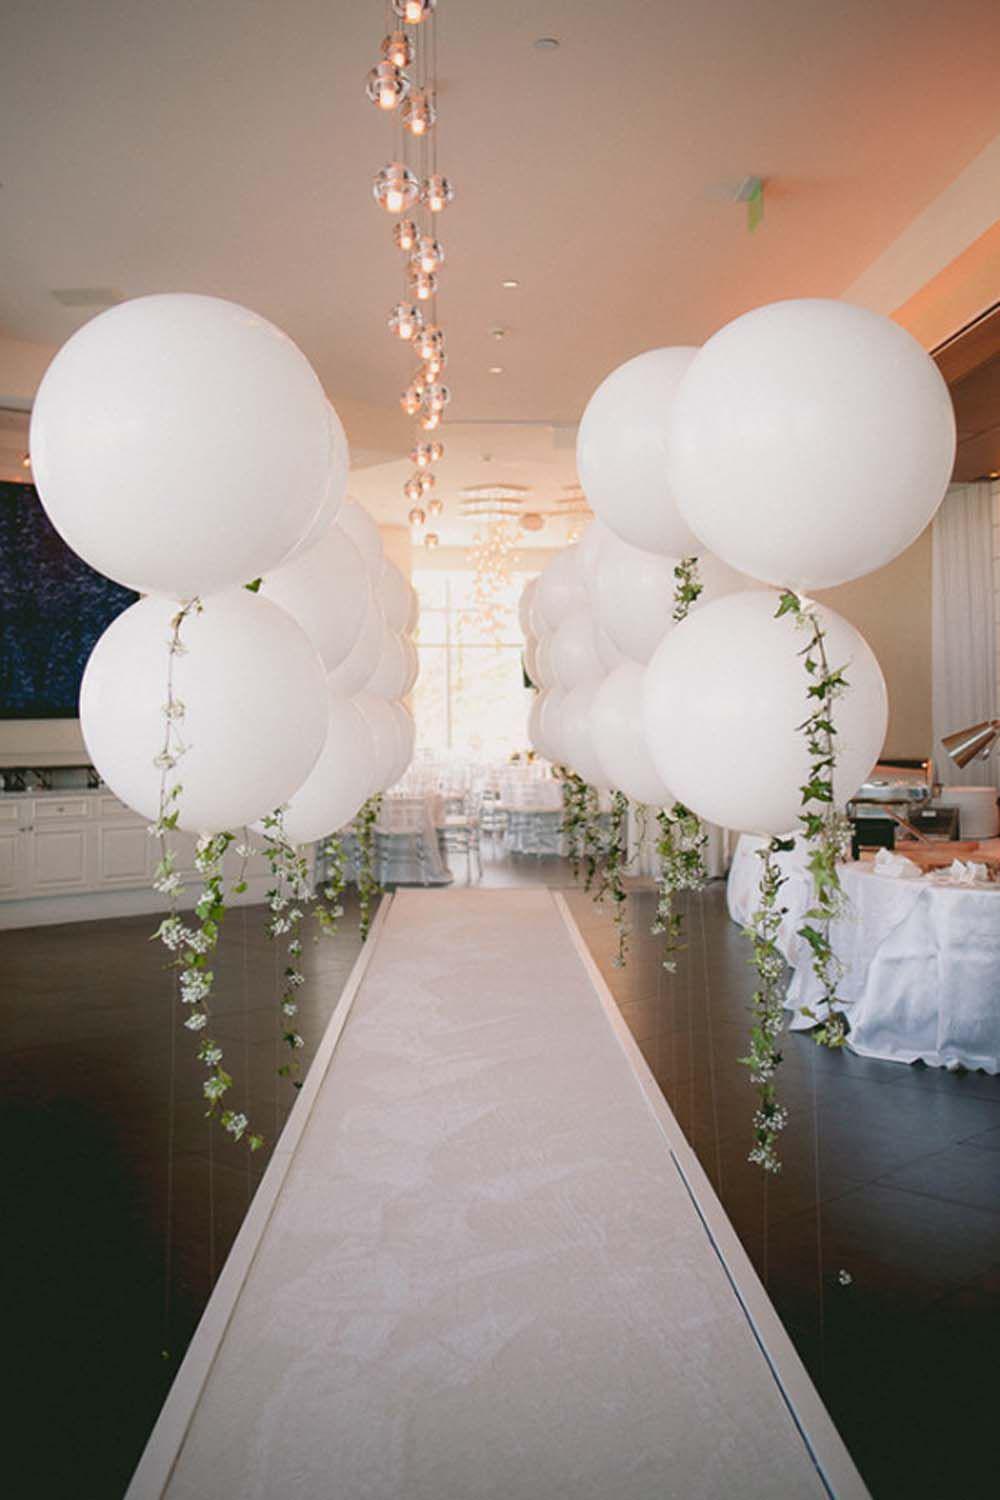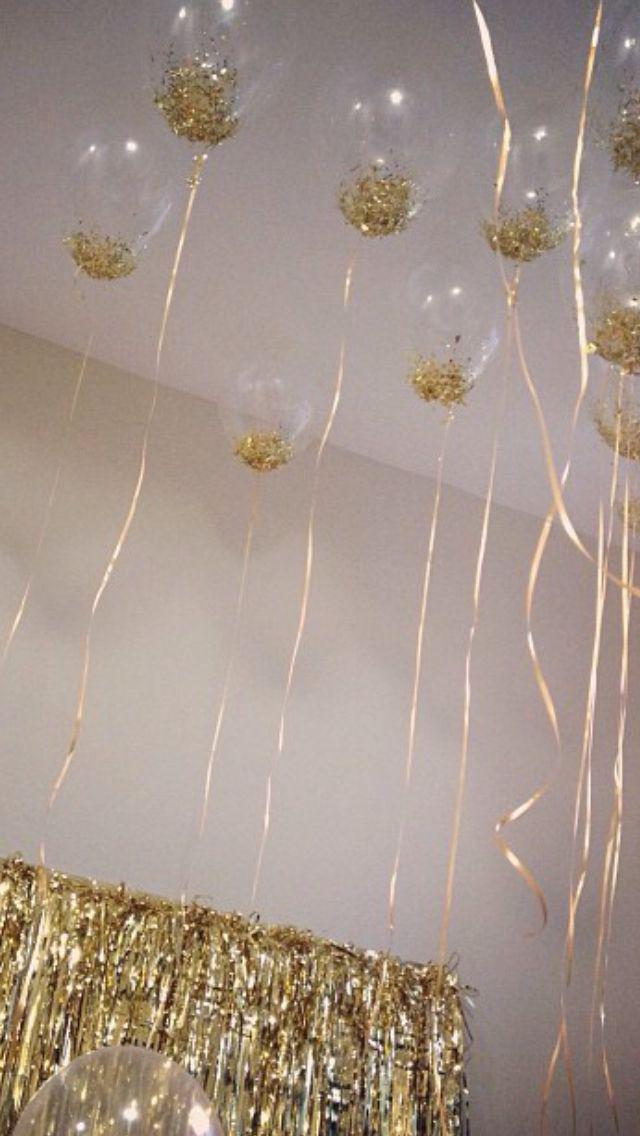The first image is the image on the left, the second image is the image on the right. Given the left and right images, does the statement "There are ornaments hanging down from balloons so clear they are nearly invisible." hold true? Answer yes or no. Yes. The first image is the image on the left, the second image is the image on the right. For the images shown, is this caption "Some balloons are clear." true? Answer yes or no. Yes. 